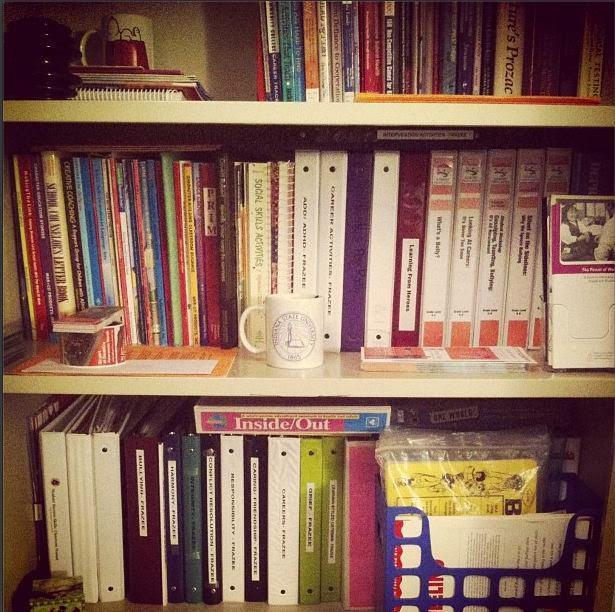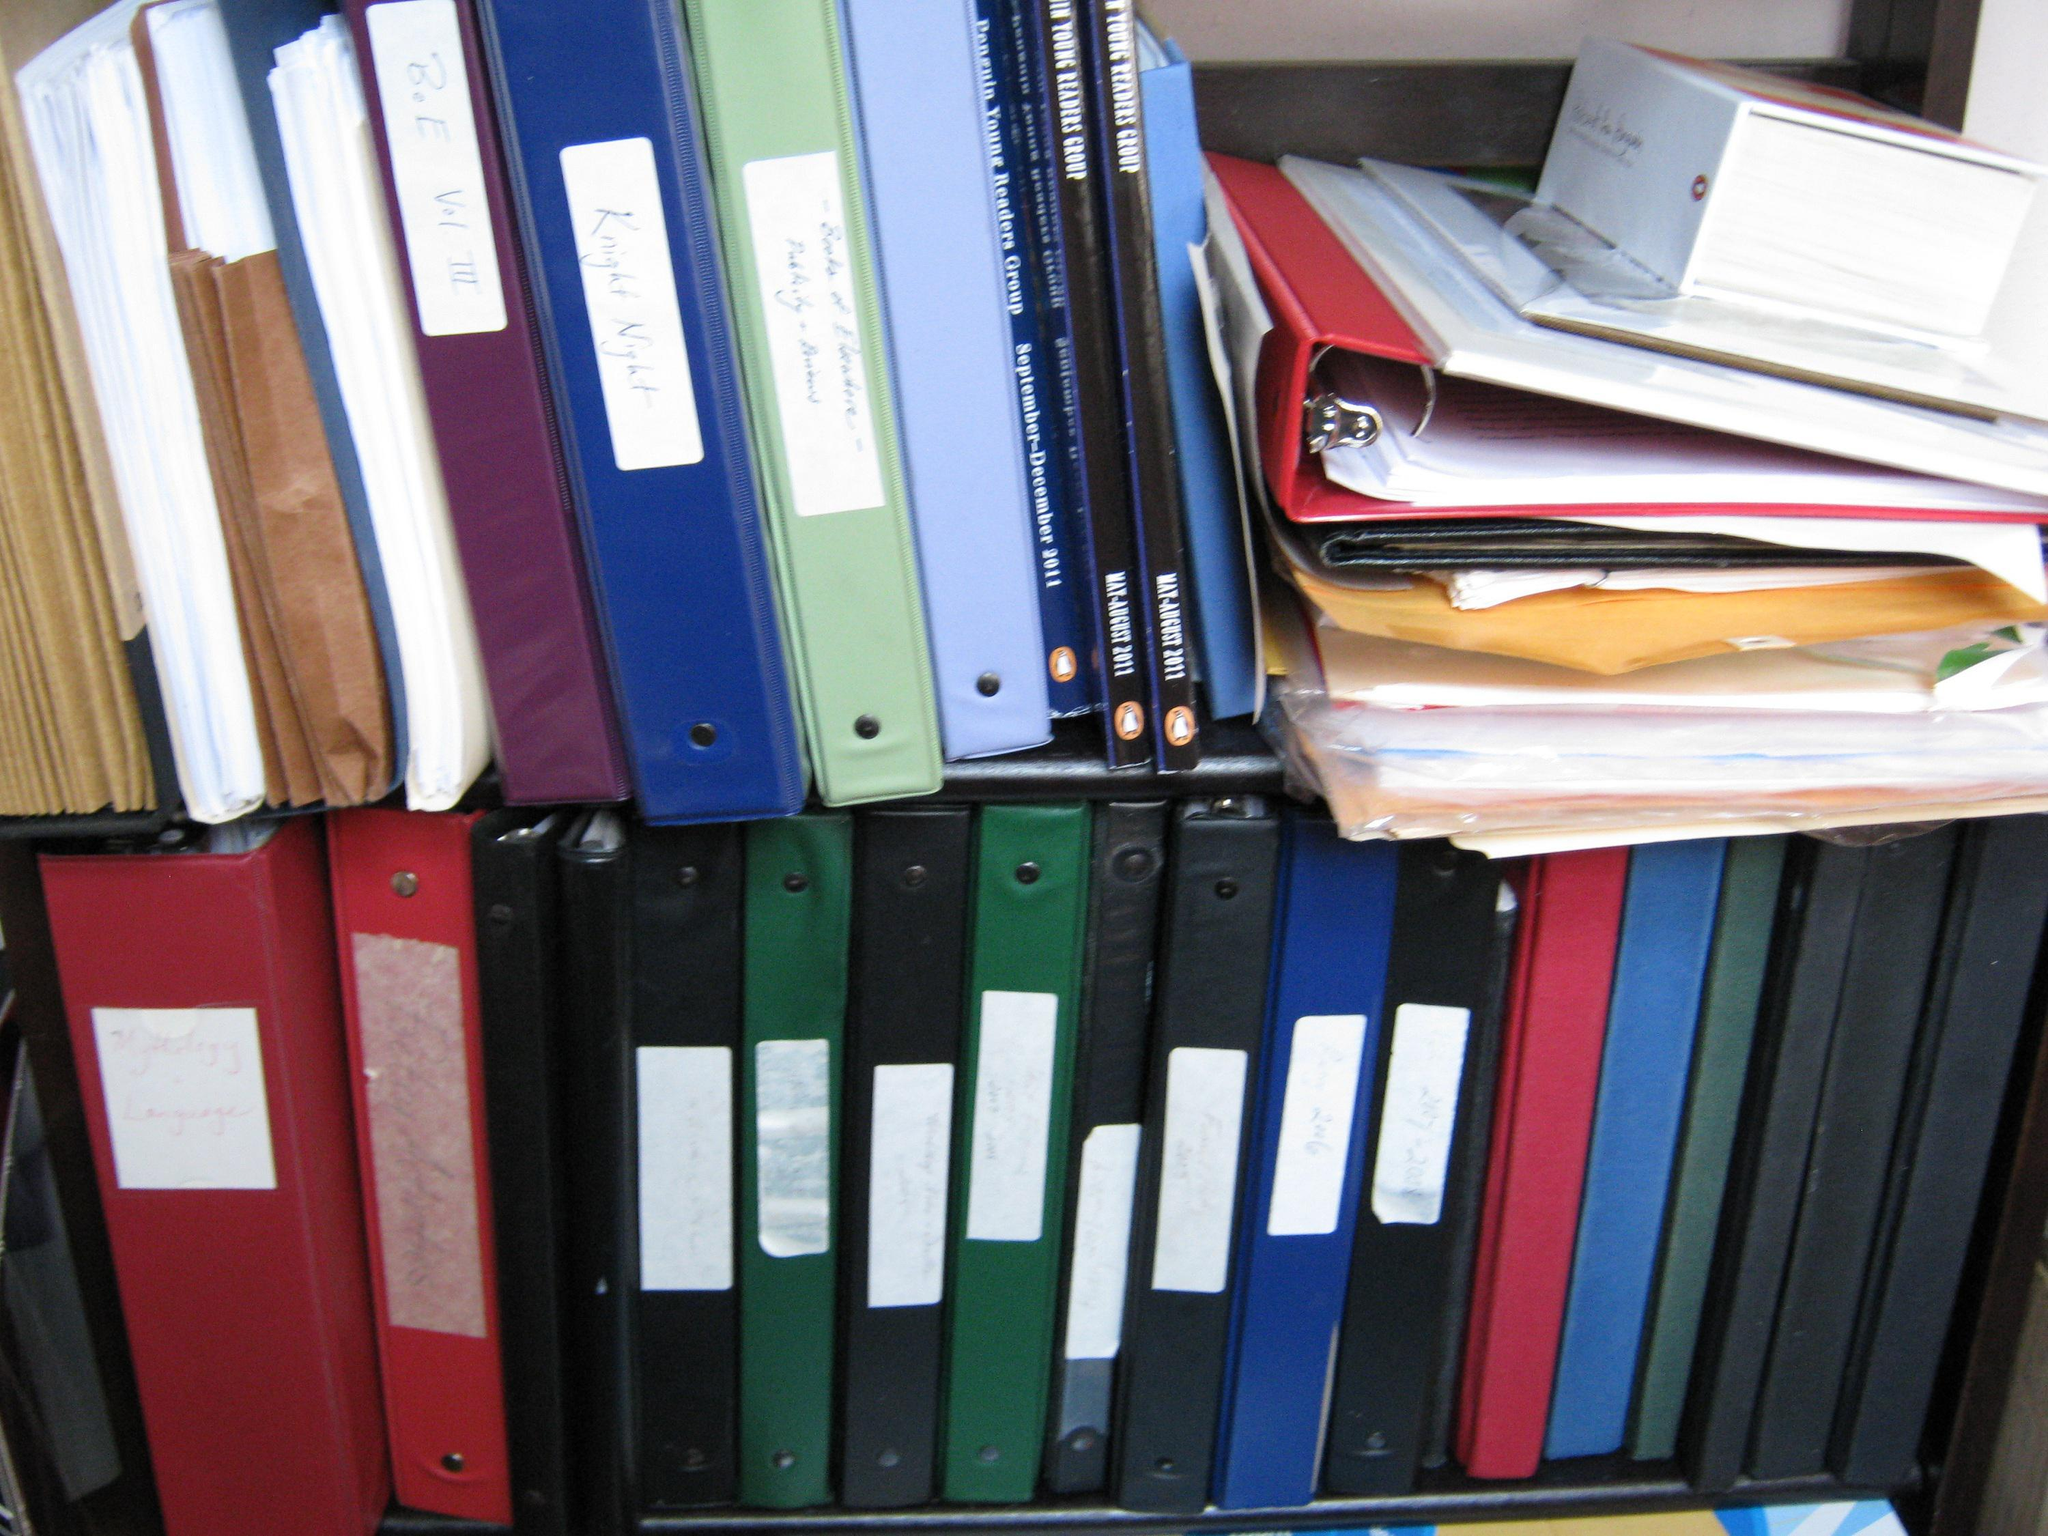The first image is the image on the left, the second image is the image on the right. Analyze the images presented: Is the assertion "there are no more than seven binders in one of the images" valid? Answer yes or no. No. 